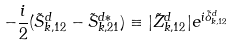Convert formula to latex. <formula><loc_0><loc_0><loc_500><loc_500>- \frac { i } { 2 } ( \tilde { S } _ { k , 1 2 } ^ { d } - \tilde { S } _ { k , 2 1 } ^ { d \ast } ) \equiv | \tilde { Z } _ { k , 1 2 } ^ { d } | e ^ { i \tilde { \delta } _ { k , 1 2 } ^ { d } }</formula> 